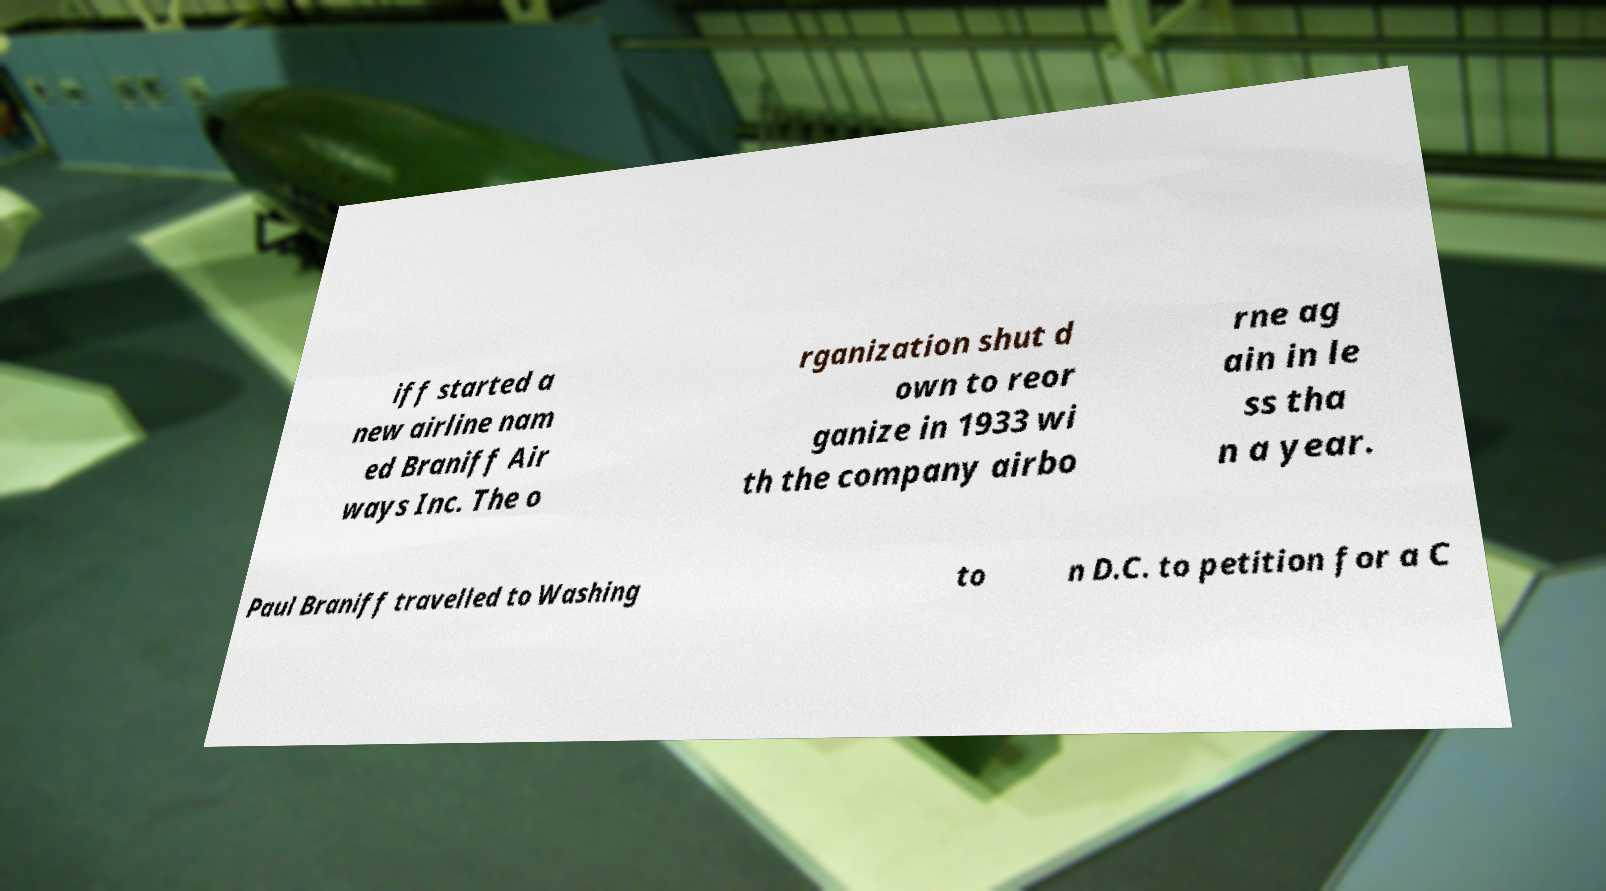Please read and relay the text visible in this image. What does it say? iff started a new airline nam ed Braniff Air ways Inc. The o rganization shut d own to reor ganize in 1933 wi th the company airbo rne ag ain in le ss tha n a year. Paul Braniff travelled to Washing to n D.C. to petition for a C 